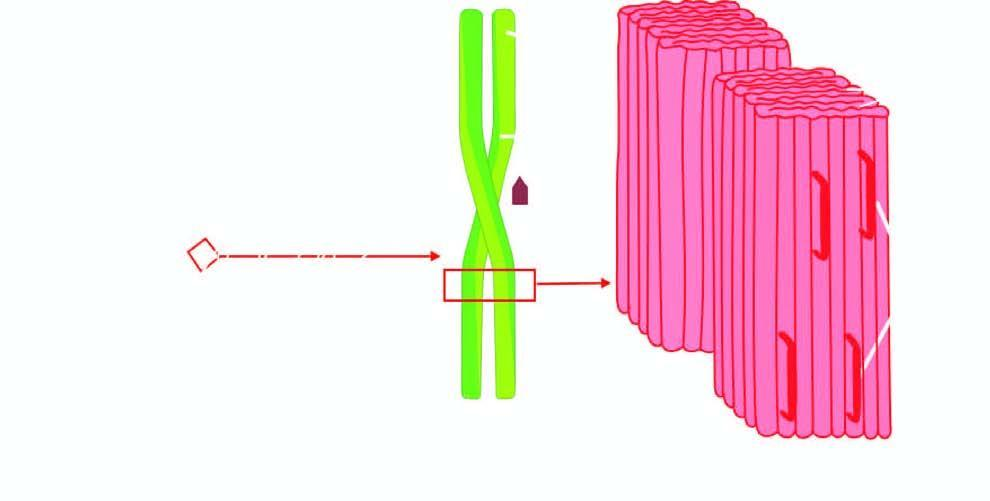what has a pentagonal or doughnut profile?
Answer the question using a single word or phrase. P-component 